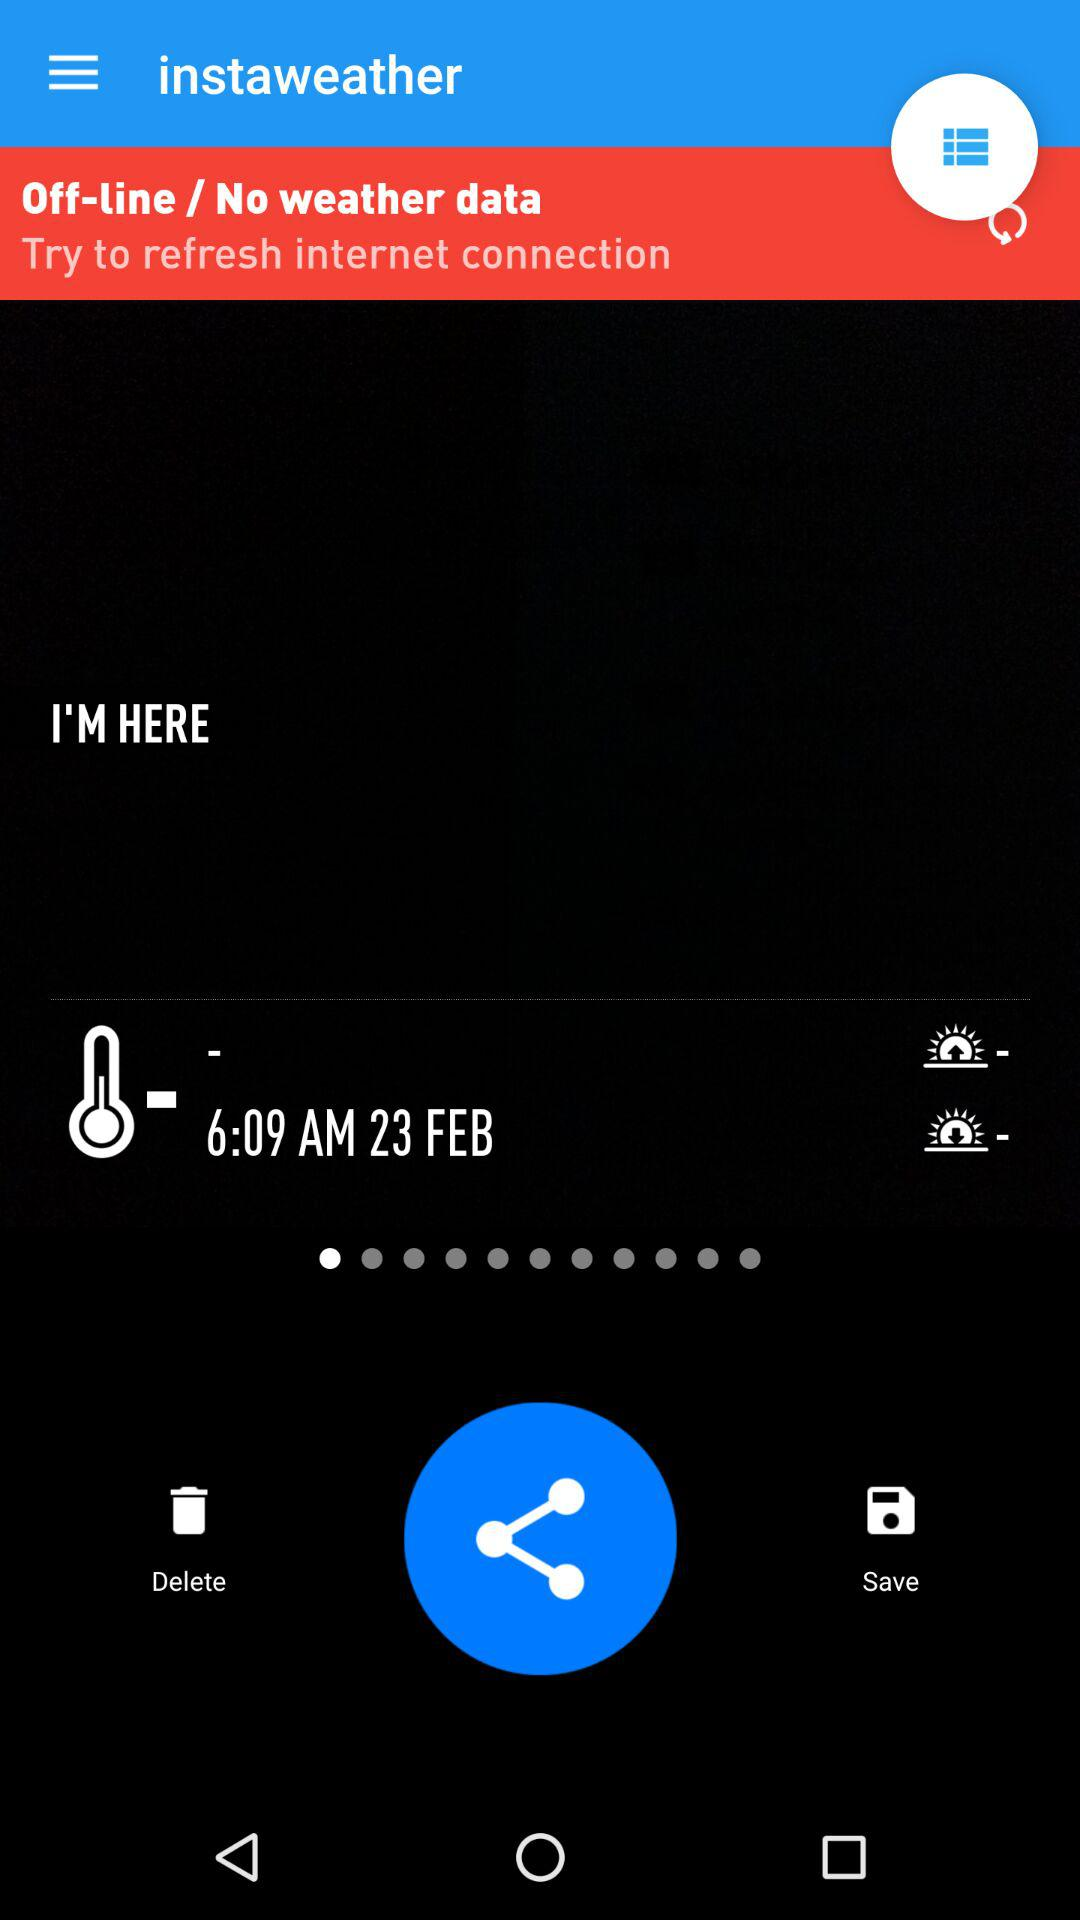What is the date? The date is February 23. 